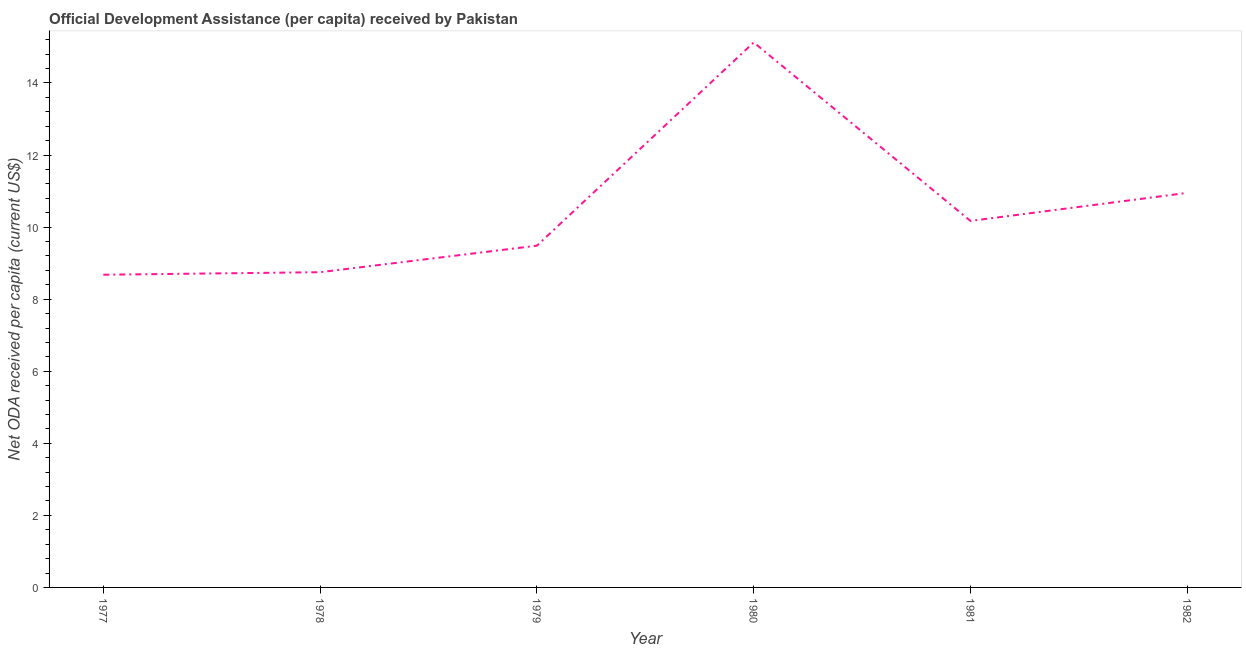What is the net oda received per capita in 1982?
Offer a terse response. 10.95. Across all years, what is the maximum net oda received per capita?
Make the answer very short. 15.13. Across all years, what is the minimum net oda received per capita?
Your answer should be compact. 8.68. What is the sum of the net oda received per capita?
Your answer should be compact. 63.16. What is the difference between the net oda received per capita in 1977 and 1979?
Provide a succinct answer. -0.81. What is the average net oda received per capita per year?
Your answer should be compact. 10.53. What is the median net oda received per capita?
Keep it short and to the point. 9.83. In how many years, is the net oda received per capita greater than 0.8 US$?
Offer a terse response. 6. Do a majority of the years between 1979 and 1980 (inclusive) have net oda received per capita greater than 12 US$?
Your answer should be very brief. No. What is the ratio of the net oda received per capita in 1981 to that in 1982?
Offer a very short reply. 0.93. Is the net oda received per capita in 1978 less than that in 1980?
Give a very brief answer. Yes. What is the difference between the highest and the second highest net oda received per capita?
Ensure brevity in your answer.  4.17. What is the difference between the highest and the lowest net oda received per capita?
Make the answer very short. 6.45. In how many years, is the net oda received per capita greater than the average net oda received per capita taken over all years?
Ensure brevity in your answer.  2. Does the net oda received per capita monotonically increase over the years?
Provide a short and direct response. No. How many lines are there?
Your answer should be very brief. 1. Does the graph contain grids?
Offer a terse response. No. What is the title of the graph?
Make the answer very short. Official Development Assistance (per capita) received by Pakistan. What is the label or title of the Y-axis?
Give a very brief answer. Net ODA received per capita (current US$). What is the Net ODA received per capita (current US$) in 1977?
Keep it short and to the point. 8.68. What is the Net ODA received per capita (current US$) of 1978?
Keep it short and to the point. 8.75. What is the Net ODA received per capita (current US$) of 1979?
Your response must be concise. 9.49. What is the Net ODA received per capita (current US$) in 1980?
Offer a terse response. 15.13. What is the Net ODA received per capita (current US$) in 1981?
Ensure brevity in your answer.  10.17. What is the Net ODA received per capita (current US$) of 1982?
Give a very brief answer. 10.95. What is the difference between the Net ODA received per capita (current US$) in 1977 and 1978?
Keep it short and to the point. -0.07. What is the difference between the Net ODA received per capita (current US$) in 1977 and 1979?
Provide a short and direct response. -0.81. What is the difference between the Net ODA received per capita (current US$) in 1977 and 1980?
Make the answer very short. -6.45. What is the difference between the Net ODA received per capita (current US$) in 1977 and 1981?
Offer a terse response. -1.49. What is the difference between the Net ODA received per capita (current US$) in 1977 and 1982?
Your answer should be very brief. -2.27. What is the difference between the Net ODA received per capita (current US$) in 1978 and 1979?
Offer a very short reply. -0.74. What is the difference between the Net ODA received per capita (current US$) in 1978 and 1980?
Ensure brevity in your answer.  -6.38. What is the difference between the Net ODA received per capita (current US$) in 1978 and 1981?
Your answer should be compact. -1.42. What is the difference between the Net ODA received per capita (current US$) in 1978 and 1982?
Provide a succinct answer. -2.2. What is the difference between the Net ODA received per capita (current US$) in 1979 and 1980?
Keep it short and to the point. -5.64. What is the difference between the Net ODA received per capita (current US$) in 1979 and 1981?
Provide a succinct answer. -0.69. What is the difference between the Net ODA received per capita (current US$) in 1979 and 1982?
Ensure brevity in your answer.  -1.47. What is the difference between the Net ODA received per capita (current US$) in 1980 and 1981?
Make the answer very short. 4.95. What is the difference between the Net ODA received per capita (current US$) in 1980 and 1982?
Offer a terse response. 4.17. What is the difference between the Net ODA received per capita (current US$) in 1981 and 1982?
Offer a terse response. -0.78. What is the ratio of the Net ODA received per capita (current US$) in 1977 to that in 1979?
Your response must be concise. 0.92. What is the ratio of the Net ODA received per capita (current US$) in 1977 to that in 1980?
Ensure brevity in your answer.  0.57. What is the ratio of the Net ODA received per capita (current US$) in 1977 to that in 1981?
Give a very brief answer. 0.85. What is the ratio of the Net ODA received per capita (current US$) in 1977 to that in 1982?
Make the answer very short. 0.79. What is the ratio of the Net ODA received per capita (current US$) in 1978 to that in 1979?
Offer a very short reply. 0.92. What is the ratio of the Net ODA received per capita (current US$) in 1978 to that in 1980?
Your answer should be compact. 0.58. What is the ratio of the Net ODA received per capita (current US$) in 1978 to that in 1981?
Provide a short and direct response. 0.86. What is the ratio of the Net ODA received per capita (current US$) in 1978 to that in 1982?
Your response must be concise. 0.8. What is the ratio of the Net ODA received per capita (current US$) in 1979 to that in 1980?
Give a very brief answer. 0.63. What is the ratio of the Net ODA received per capita (current US$) in 1979 to that in 1981?
Offer a very short reply. 0.93. What is the ratio of the Net ODA received per capita (current US$) in 1979 to that in 1982?
Provide a succinct answer. 0.87. What is the ratio of the Net ODA received per capita (current US$) in 1980 to that in 1981?
Your response must be concise. 1.49. What is the ratio of the Net ODA received per capita (current US$) in 1980 to that in 1982?
Give a very brief answer. 1.38. What is the ratio of the Net ODA received per capita (current US$) in 1981 to that in 1982?
Give a very brief answer. 0.93. 